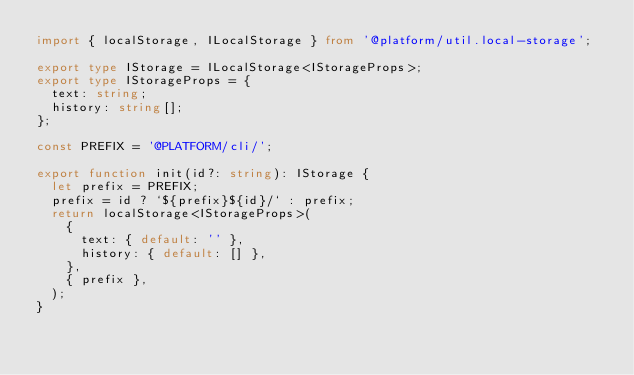<code> <loc_0><loc_0><loc_500><loc_500><_TypeScript_>import { localStorage, ILocalStorage } from '@platform/util.local-storage';

export type IStorage = ILocalStorage<IStorageProps>;
export type IStorageProps = {
  text: string;
  history: string[];
};

const PREFIX = '@PLATFORM/cli/';

export function init(id?: string): IStorage {
  let prefix = PREFIX;
  prefix = id ? `${prefix}${id}/` : prefix;
  return localStorage<IStorageProps>(
    {
      text: { default: '' },
      history: { default: [] },
    },
    { prefix },
  );
}
</code> 